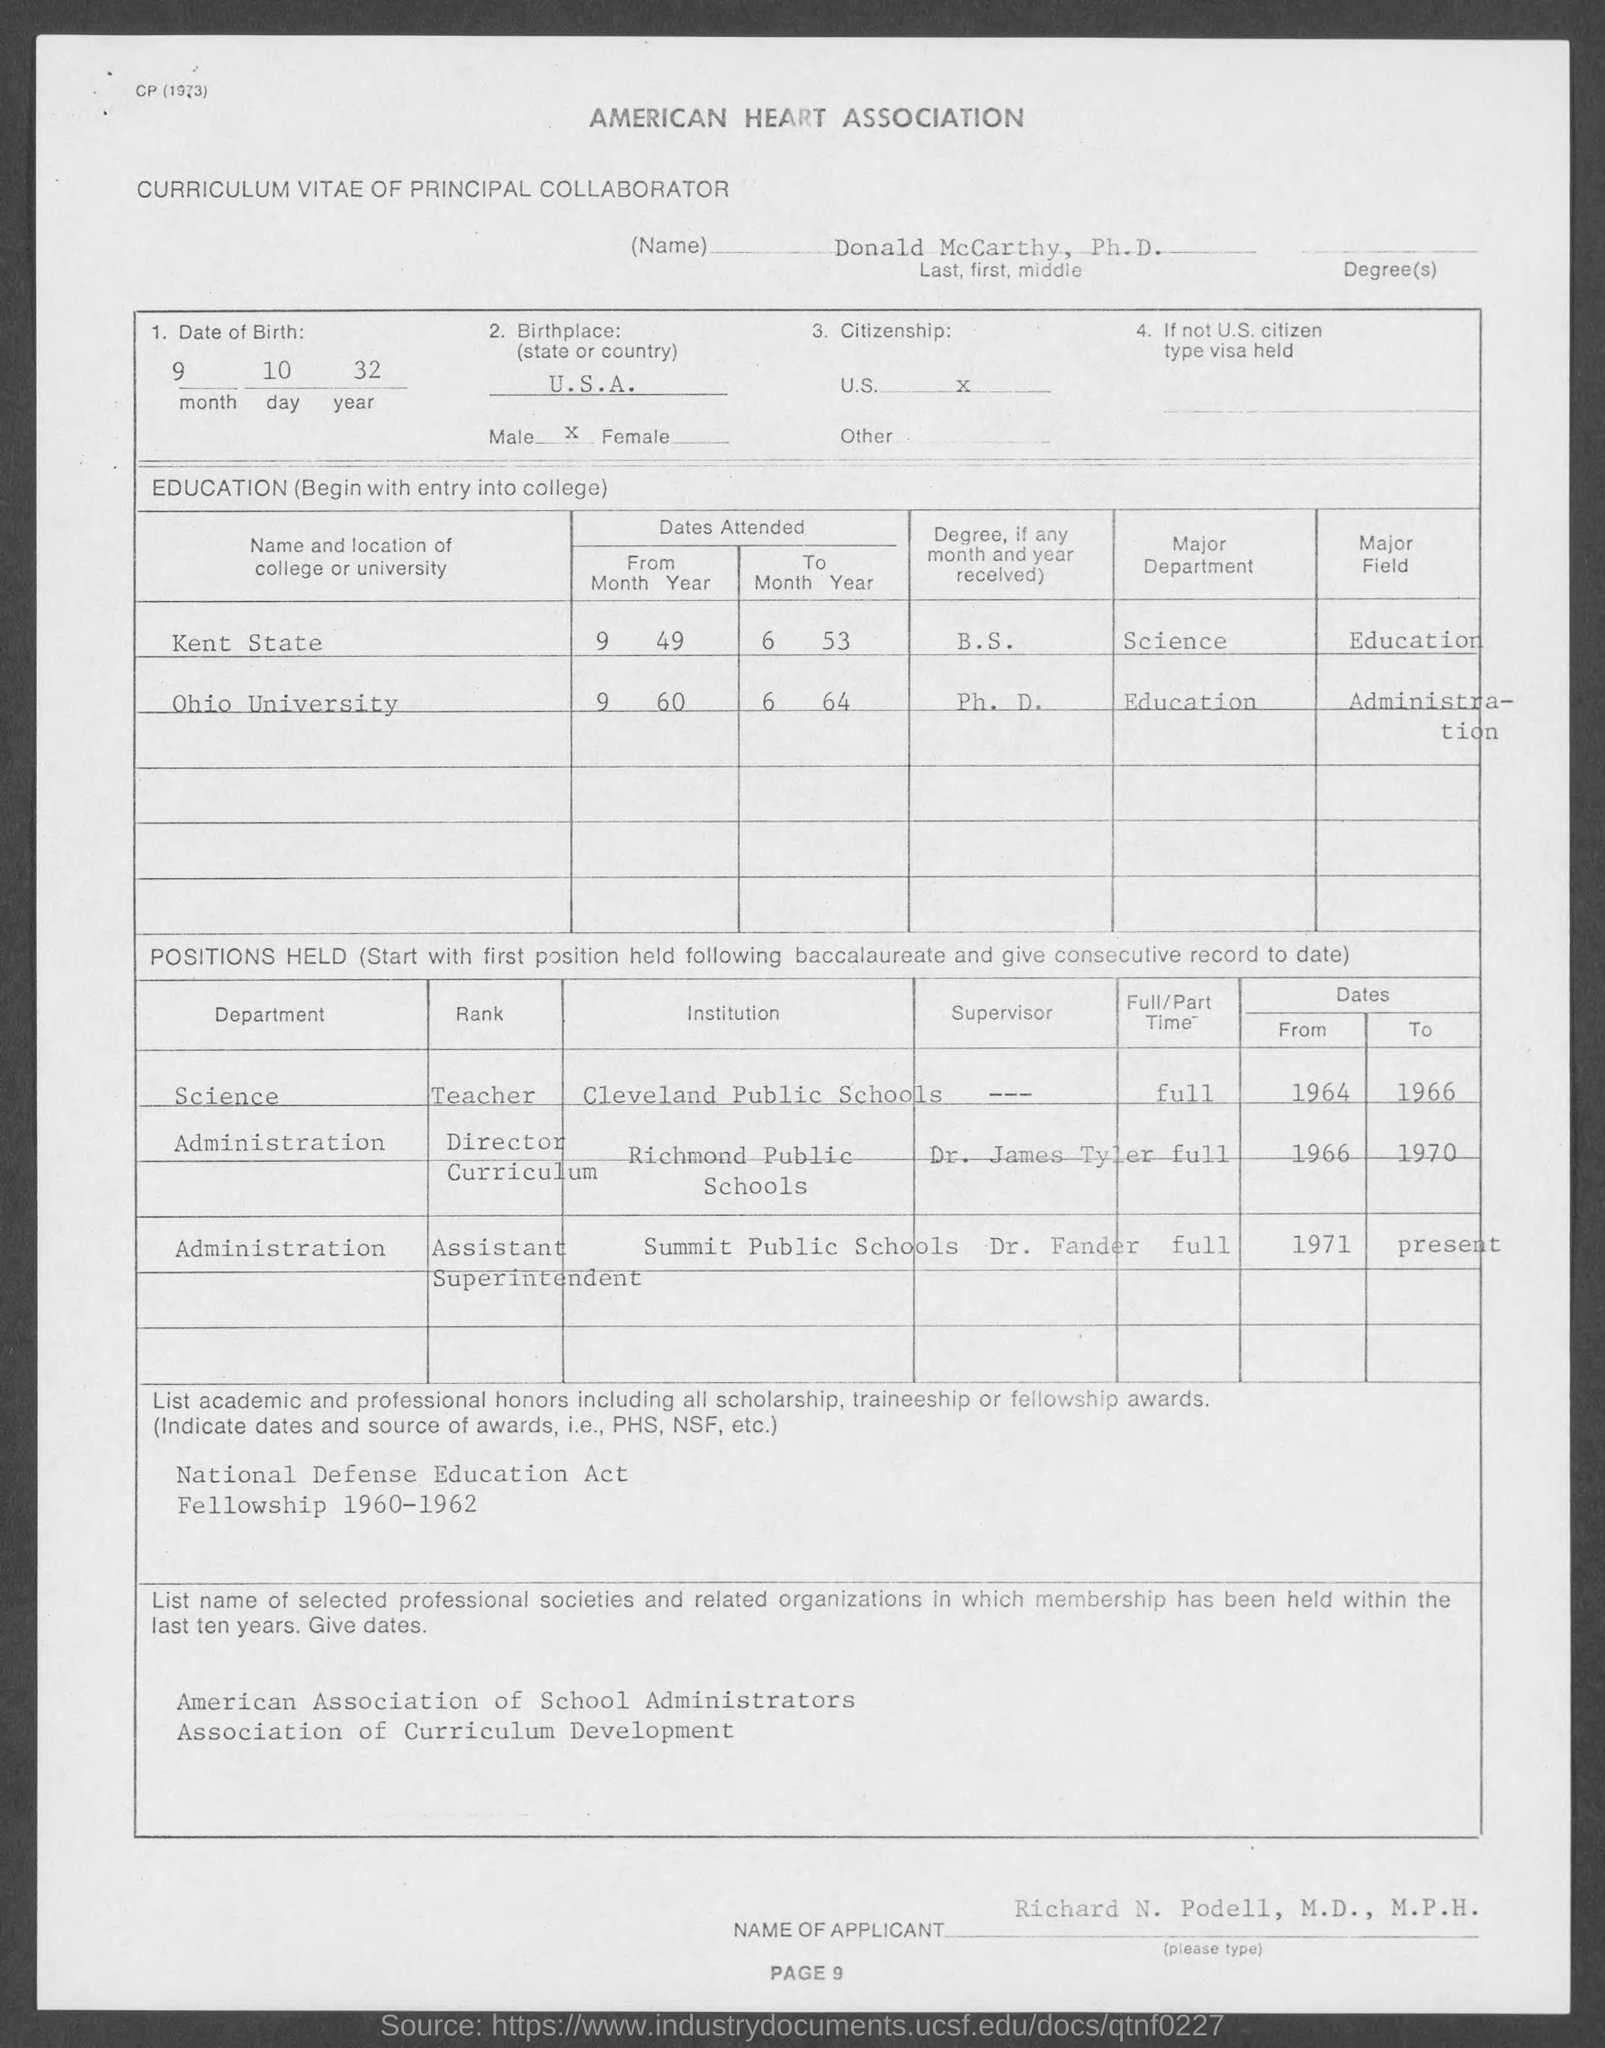Draw attention to some important aspects in this diagram. The American Heart Association is the name of the heart association that is at the top. The date of birth is September 10, 1932. 